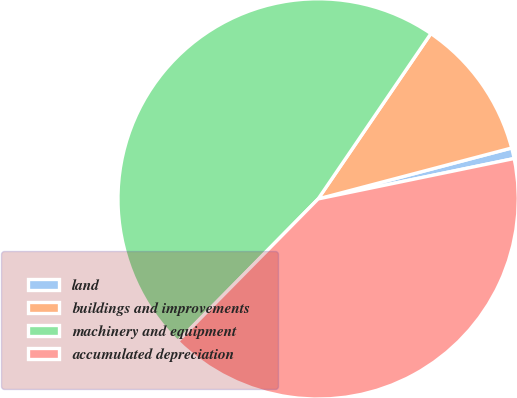<chart> <loc_0><loc_0><loc_500><loc_500><pie_chart><fcel>land<fcel>buildings and improvements<fcel>machinery and equipment<fcel>accumulated depreciation<nl><fcel>0.86%<fcel>11.38%<fcel>47.15%<fcel>40.62%<nl></chart> 